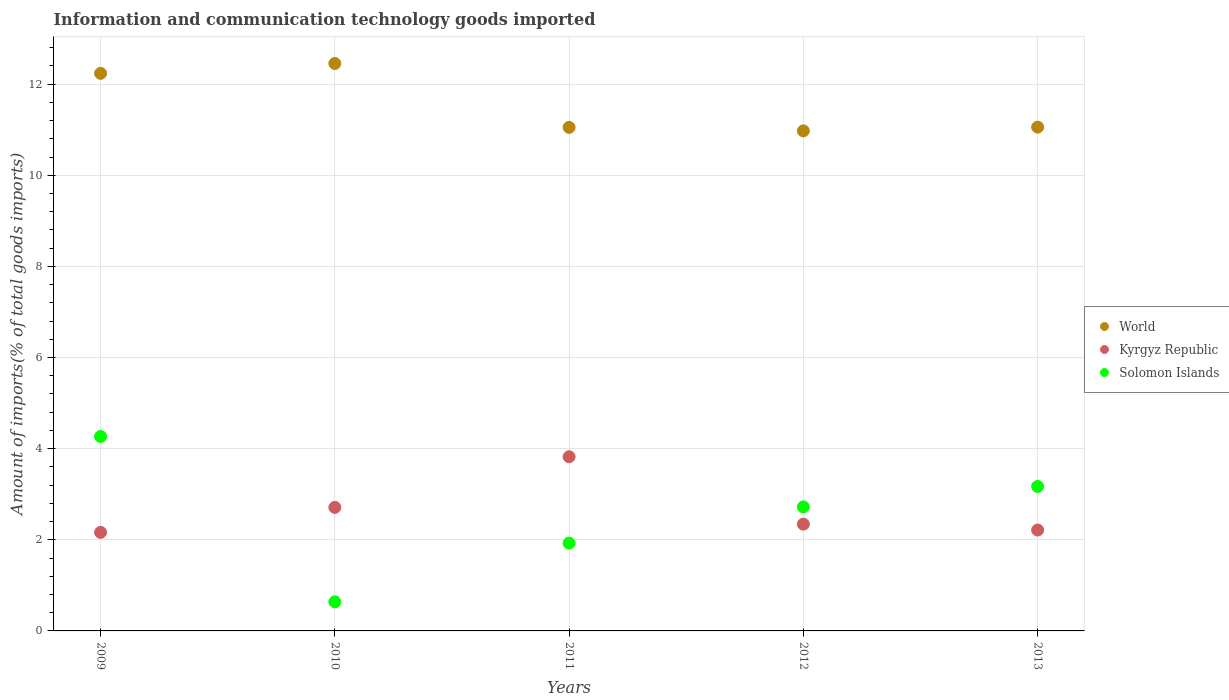How many different coloured dotlines are there?
Give a very brief answer. 3. What is the amount of goods imported in World in 2009?
Provide a succinct answer. 12.24. Across all years, what is the maximum amount of goods imported in Kyrgyz Republic?
Make the answer very short. 3.82. Across all years, what is the minimum amount of goods imported in World?
Keep it short and to the point. 10.97. What is the total amount of goods imported in Solomon Islands in the graph?
Give a very brief answer. 12.73. What is the difference between the amount of goods imported in World in 2009 and that in 2013?
Keep it short and to the point. 1.18. What is the difference between the amount of goods imported in World in 2011 and the amount of goods imported in Solomon Islands in 2010?
Make the answer very short. 10.41. What is the average amount of goods imported in Solomon Islands per year?
Provide a succinct answer. 2.55. In the year 2013, what is the difference between the amount of goods imported in World and amount of goods imported in Solomon Islands?
Offer a terse response. 7.89. In how many years, is the amount of goods imported in Kyrgyz Republic greater than 11.6 %?
Ensure brevity in your answer.  0. What is the ratio of the amount of goods imported in World in 2010 to that in 2013?
Offer a terse response. 1.13. Is the amount of goods imported in World in 2010 less than that in 2012?
Keep it short and to the point. No. Is the difference between the amount of goods imported in World in 2009 and 2013 greater than the difference between the amount of goods imported in Solomon Islands in 2009 and 2013?
Your answer should be compact. Yes. What is the difference between the highest and the second highest amount of goods imported in Solomon Islands?
Your answer should be very brief. 1.1. What is the difference between the highest and the lowest amount of goods imported in Solomon Islands?
Ensure brevity in your answer.  3.63. Does the amount of goods imported in Solomon Islands monotonically increase over the years?
Ensure brevity in your answer.  No. Is the amount of goods imported in Solomon Islands strictly less than the amount of goods imported in Kyrgyz Republic over the years?
Give a very brief answer. No. What is the difference between two consecutive major ticks on the Y-axis?
Keep it short and to the point. 2. How are the legend labels stacked?
Your answer should be very brief. Vertical. What is the title of the graph?
Make the answer very short. Information and communication technology goods imported. Does "Gambia, The" appear as one of the legend labels in the graph?
Your answer should be very brief. No. What is the label or title of the Y-axis?
Make the answer very short. Amount of imports(% of total goods imports). What is the Amount of imports(% of total goods imports) in World in 2009?
Offer a terse response. 12.24. What is the Amount of imports(% of total goods imports) of Kyrgyz Republic in 2009?
Make the answer very short. 2.16. What is the Amount of imports(% of total goods imports) of Solomon Islands in 2009?
Ensure brevity in your answer.  4.27. What is the Amount of imports(% of total goods imports) of World in 2010?
Provide a short and direct response. 12.45. What is the Amount of imports(% of total goods imports) in Kyrgyz Republic in 2010?
Provide a succinct answer. 2.71. What is the Amount of imports(% of total goods imports) in Solomon Islands in 2010?
Make the answer very short. 0.64. What is the Amount of imports(% of total goods imports) in World in 2011?
Keep it short and to the point. 11.05. What is the Amount of imports(% of total goods imports) in Kyrgyz Republic in 2011?
Offer a very short reply. 3.82. What is the Amount of imports(% of total goods imports) in Solomon Islands in 2011?
Your answer should be very brief. 1.93. What is the Amount of imports(% of total goods imports) of World in 2012?
Give a very brief answer. 10.97. What is the Amount of imports(% of total goods imports) of Kyrgyz Republic in 2012?
Give a very brief answer. 2.34. What is the Amount of imports(% of total goods imports) of Solomon Islands in 2012?
Ensure brevity in your answer.  2.72. What is the Amount of imports(% of total goods imports) of World in 2013?
Ensure brevity in your answer.  11.06. What is the Amount of imports(% of total goods imports) in Kyrgyz Republic in 2013?
Make the answer very short. 2.21. What is the Amount of imports(% of total goods imports) of Solomon Islands in 2013?
Ensure brevity in your answer.  3.17. Across all years, what is the maximum Amount of imports(% of total goods imports) in World?
Ensure brevity in your answer.  12.45. Across all years, what is the maximum Amount of imports(% of total goods imports) in Kyrgyz Republic?
Ensure brevity in your answer.  3.82. Across all years, what is the maximum Amount of imports(% of total goods imports) in Solomon Islands?
Ensure brevity in your answer.  4.27. Across all years, what is the minimum Amount of imports(% of total goods imports) in World?
Your answer should be compact. 10.97. Across all years, what is the minimum Amount of imports(% of total goods imports) of Kyrgyz Republic?
Make the answer very short. 2.16. Across all years, what is the minimum Amount of imports(% of total goods imports) of Solomon Islands?
Provide a succinct answer. 0.64. What is the total Amount of imports(% of total goods imports) of World in the graph?
Your answer should be compact. 57.77. What is the total Amount of imports(% of total goods imports) in Kyrgyz Republic in the graph?
Ensure brevity in your answer.  13.25. What is the total Amount of imports(% of total goods imports) of Solomon Islands in the graph?
Offer a very short reply. 12.73. What is the difference between the Amount of imports(% of total goods imports) in World in 2009 and that in 2010?
Keep it short and to the point. -0.22. What is the difference between the Amount of imports(% of total goods imports) in Kyrgyz Republic in 2009 and that in 2010?
Make the answer very short. -0.55. What is the difference between the Amount of imports(% of total goods imports) of Solomon Islands in 2009 and that in 2010?
Provide a succinct answer. 3.63. What is the difference between the Amount of imports(% of total goods imports) in World in 2009 and that in 2011?
Your answer should be compact. 1.19. What is the difference between the Amount of imports(% of total goods imports) in Kyrgyz Republic in 2009 and that in 2011?
Your answer should be very brief. -1.66. What is the difference between the Amount of imports(% of total goods imports) of Solomon Islands in 2009 and that in 2011?
Your response must be concise. 2.34. What is the difference between the Amount of imports(% of total goods imports) in World in 2009 and that in 2012?
Keep it short and to the point. 1.26. What is the difference between the Amount of imports(% of total goods imports) in Kyrgyz Republic in 2009 and that in 2012?
Provide a succinct answer. -0.18. What is the difference between the Amount of imports(% of total goods imports) in Solomon Islands in 2009 and that in 2012?
Offer a very short reply. 1.55. What is the difference between the Amount of imports(% of total goods imports) of World in 2009 and that in 2013?
Your answer should be compact. 1.18. What is the difference between the Amount of imports(% of total goods imports) of Kyrgyz Republic in 2009 and that in 2013?
Your answer should be very brief. -0.05. What is the difference between the Amount of imports(% of total goods imports) in Solomon Islands in 2009 and that in 2013?
Give a very brief answer. 1.1. What is the difference between the Amount of imports(% of total goods imports) of World in 2010 and that in 2011?
Offer a terse response. 1.4. What is the difference between the Amount of imports(% of total goods imports) in Kyrgyz Republic in 2010 and that in 2011?
Keep it short and to the point. -1.11. What is the difference between the Amount of imports(% of total goods imports) of Solomon Islands in 2010 and that in 2011?
Provide a succinct answer. -1.29. What is the difference between the Amount of imports(% of total goods imports) of World in 2010 and that in 2012?
Provide a short and direct response. 1.48. What is the difference between the Amount of imports(% of total goods imports) in Kyrgyz Republic in 2010 and that in 2012?
Your answer should be compact. 0.37. What is the difference between the Amount of imports(% of total goods imports) in Solomon Islands in 2010 and that in 2012?
Keep it short and to the point. -2.08. What is the difference between the Amount of imports(% of total goods imports) in World in 2010 and that in 2013?
Provide a short and direct response. 1.4. What is the difference between the Amount of imports(% of total goods imports) in Kyrgyz Republic in 2010 and that in 2013?
Offer a terse response. 0.5. What is the difference between the Amount of imports(% of total goods imports) in Solomon Islands in 2010 and that in 2013?
Ensure brevity in your answer.  -2.53. What is the difference between the Amount of imports(% of total goods imports) of World in 2011 and that in 2012?
Provide a succinct answer. 0.08. What is the difference between the Amount of imports(% of total goods imports) in Kyrgyz Republic in 2011 and that in 2012?
Provide a short and direct response. 1.48. What is the difference between the Amount of imports(% of total goods imports) of Solomon Islands in 2011 and that in 2012?
Keep it short and to the point. -0.8. What is the difference between the Amount of imports(% of total goods imports) of World in 2011 and that in 2013?
Keep it short and to the point. -0.01. What is the difference between the Amount of imports(% of total goods imports) of Kyrgyz Republic in 2011 and that in 2013?
Provide a short and direct response. 1.61. What is the difference between the Amount of imports(% of total goods imports) of Solomon Islands in 2011 and that in 2013?
Offer a very short reply. -1.24. What is the difference between the Amount of imports(% of total goods imports) of World in 2012 and that in 2013?
Your answer should be compact. -0.08. What is the difference between the Amount of imports(% of total goods imports) in Kyrgyz Republic in 2012 and that in 2013?
Keep it short and to the point. 0.13. What is the difference between the Amount of imports(% of total goods imports) in Solomon Islands in 2012 and that in 2013?
Give a very brief answer. -0.45. What is the difference between the Amount of imports(% of total goods imports) of World in 2009 and the Amount of imports(% of total goods imports) of Kyrgyz Republic in 2010?
Offer a very short reply. 9.53. What is the difference between the Amount of imports(% of total goods imports) of World in 2009 and the Amount of imports(% of total goods imports) of Solomon Islands in 2010?
Your response must be concise. 11.6. What is the difference between the Amount of imports(% of total goods imports) in Kyrgyz Republic in 2009 and the Amount of imports(% of total goods imports) in Solomon Islands in 2010?
Give a very brief answer. 1.52. What is the difference between the Amount of imports(% of total goods imports) of World in 2009 and the Amount of imports(% of total goods imports) of Kyrgyz Republic in 2011?
Provide a short and direct response. 8.41. What is the difference between the Amount of imports(% of total goods imports) of World in 2009 and the Amount of imports(% of total goods imports) of Solomon Islands in 2011?
Provide a succinct answer. 10.31. What is the difference between the Amount of imports(% of total goods imports) of Kyrgyz Republic in 2009 and the Amount of imports(% of total goods imports) of Solomon Islands in 2011?
Give a very brief answer. 0.24. What is the difference between the Amount of imports(% of total goods imports) of World in 2009 and the Amount of imports(% of total goods imports) of Kyrgyz Republic in 2012?
Your answer should be compact. 9.89. What is the difference between the Amount of imports(% of total goods imports) in World in 2009 and the Amount of imports(% of total goods imports) in Solomon Islands in 2012?
Your answer should be compact. 9.51. What is the difference between the Amount of imports(% of total goods imports) in Kyrgyz Republic in 2009 and the Amount of imports(% of total goods imports) in Solomon Islands in 2012?
Your response must be concise. -0.56. What is the difference between the Amount of imports(% of total goods imports) in World in 2009 and the Amount of imports(% of total goods imports) in Kyrgyz Republic in 2013?
Provide a succinct answer. 10.02. What is the difference between the Amount of imports(% of total goods imports) of World in 2009 and the Amount of imports(% of total goods imports) of Solomon Islands in 2013?
Keep it short and to the point. 9.07. What is the difference between the Amount of imports(% of total goods imports) in Kyrgyz Republic in 2009 and the Amount of imports(% of total goods imports) in Solomon Islands in 2013?
Provide a succinct answer. -1.01. What is the difference between the Amount of imports(% of total goods imports) of World in 2010 and the Amount of imports(% of total goods imports) of Kyrgyz Republic in 2011?
Provide a succinct answer. 8.63. What is the difference between the Amount of imports(% of total goods imports) of World in 2010 and the Amount of imports(% of total goods imports) of Solomon Islands in 2011?
Provide a succinct answer. 10.53. What is the difference between the Amount of imports(% of total goods imports) in Kyrgyz Republic in 2010 and the Amount of imports(% of total goods imports) in Solomon Islands in 2011?
Give a very brief answer. 0.78. What is the difference between the Amount of imports(% of total goods imports) in World in 2010 and the Amount of imports(% of total goods imports) in Kyrgyz Republic in 2012?
Make the answer very short. 10.11. What is the difference between the Amount of imports(% of total goods imports) in World in 2010 and the Amount of imports(% of total goods imports) in Solomon Islands in 2012?
Provide a short and direct response. 9.73. What is the difference between the Amount of imports(% of total goods imports) in Kyrgyz Republic in 2010 and the Amount of imports(% of total goods imports) in Solomon Islands in 2012?
Make the answer very short. -0.01. What is the difference between the Amount of imports(% of total goods imports) in World in 2010 and the Amount of imports(% of total goods imports) in Kyrgyz Republic in 2013?
Give a very brief answer. 10.24. What is the difference between the Amount of imports(% of total goods imports) of World in 2010 and the Amount of imports(% of total goods imports) of Solomon Islands in 2013?
Offer a terse response. 9.28. What is the difference between the Amount of imports(% of total goods imports) in Kyrgyz Republic in 2010 and the Amount of imports(% of total goods imports) in Solomon Islands in 2013?
Make the answer very short. -0.46. What is the difference between the Amount of imports(% of total goods imports) of World in 2011 and the Amount of imports(% of total goods imports) of Kyrgyz Republic in 2012?
Your response must be concise. 8.71. What is the difference between the Amount of imports(% of total goods imports) in World in 2011 and the Amount of imports(% of total goods imports) in Solomon Islands in 2012?
Give a very brief answer. 8.33. What is the difference between the Amount of imports(% of total goods imports) in Kyrgyz Republic in 2011 and the Amount of imports(% of total goods imports) in Solomon Islands in 2012?
Make the answer very short. 1.1. What is the difference between the Amount of imports(% of total goods imports) in World in 2011 and the Amount of imports(% of total goods imports) in Kyrgyz Republic in 2013?
Your response must be concise. 8.84. What is the difference between the Amount of imports(% of total goods imports) of World in 2011 and the Amount of imports(% of total goods imports) of Solomon Islands in 2013?
Make the answer very short. 7.88. What is the difference between the Amount of imports(% of total goods imports) of Kyrgyz Republic in 2011 and the Amount of imports(% of total goods imports) of Solomon Islands in 2013?
Make the answer very short. 0.65. What is the difference between the Amount of imports(% of total goods imports) of World in 2012 and the Amount of imports(% of total goods imports) of Kyrgyz Republic in 2013?
Your answer should be compact. 8.76. What is the difference between the Amount of imports(% of total goods imports) of World in 2012 and the Amount of imports(% of total goods imports) of Solomon Islands in 2013?
Offer a very short reply. 7.8. What is the difference between the Amount of imports(% of total goods imports) of Kyrgyz Republic in 2012 and the Amount of imports(% of total goods imports) of Solomon Islands in 2013?
Your answer should be compact. -0.83. What is the average Amount of imports(% of total goods imports) of World per year?
Give a very brief answer. 11.55. What is the average Amount of imports(% of total goods imports) in Kyrgyz Republic per year?
Your answer should be very brief. 2.65. What is the average Amount of imports(% of total goods imports) in Solomon Islands per year?
Your answer should be very brief. 2.55. In the year 2009, what is the difference between the Amount of imports(% of total goods imports) in World and Amount of imports(% of total goods imports) in Kyrgyz Republic?
Provide a short and direct response. 10.07. In the year 2009, what is the difference between the Amount of imports(% of total goods imports) of World and Amount of imports(% of total goods imports) of Solomon Islands?
Offer a very short reply. 7.97. In the year 2009, what is the difference between the Amount of imports(% of total goods imports) of Kyrgyz Republic and Amount of imports(% of total goods imports) of Solomon Islands?
Make the answer very short. -2.1. In the year 2010, what is the difference between the Amount of imports(% of total goods imports) in World and Amount of imports(% of total goods imports) in Kyrgyz Republic?
Give a very brief answer. 9.74. In the year 2010, what is the difference between the Amount of imports(% of total goods imports) of World and Amount of imports(% of total goods imports) of Solomon Islands?
Offer a terse response. 11.81. In the year 2010, what is the difference between the Amount of imports(% of total goods imports) of Kyrgyz Republic and Amount of imports(% of total goods imports) of Solomon Islands?
Your answer should be very brief. 2.07. In the year 2011, what is the difference between the Amount of imports(% of total goods imports) of World and Amount of imports(% of total goods imports) of Kyrgyz Republic?
Your answer should be very brief. 7.23. In the year 2011, what is the difference between the Amount of imports(% of total goods imports) of World and Amount of imports(% of total goods imports) of Solomon Islands?
Make the answer very short. 9.12. In the year 2011, what is the difference between the Amount of imports(% of total goods imports) of Kyrgyz Republic and Amount of imports(% of total goods imports) of Solomon Islands?
Your response must be concise. 1.9. In the year 2012, what is the difference between the Amount of imports(% of total goods imports) of World and Amount of imports(% of total goods imports) of Kyrgyz Republic?
Offer a very short reply. 8.63. In the year 2012, what is the difference between the Amount of imports(% of total goods imports) in World and Amount of imports(% of total goods imports) in Solomon Islands?
Provide a succinct answer. 8.25. In the year 2012, what is the difference between the Amount of imports(% of total goods imports) in Kyrgyz Republic and Amount of imports(% of total goods imports) in Solomon Islands?
Offer a terse response. -0.38. In the year 2013, what is the difference between the Amount of imports(% of total goods imports) in World and Amount of imports(% of total goods imports) in Kyrgyz Republic?
Provide a short and direct response. 8.84. In the year 2013, what is the difference between the Amount of imports(% of total goods imports) in World and Amount of imports(% of total goods imports) in Solomon Islands?
Give a very brief answer. 7.89. In the year 2013, what is the difference between the Amount of imports(% of total goods imports) of Kyrgyz Republic and Amount of imports(% of total goods imports) of Solomon Islands?
Keep it short and to the point. -0.96. What is the ratio of the Amount of imports(% of total goods imports) in World in 2009 to that in 2010?
Your answer should be very brief. 0.98. What is the ratio of the Amount of imports(% of total goods imports) of Kyrgyz Republic in 2009 to that in 2010?
Offer a very short reply. 0.8. What is the ratio of the Amount of imports(% of total goods imports) in Solomon Islands in 2009 to that in 2010?
Ensure brevity in your answer.  6.68. What is the ratio of the Amount of imports(% of total goods imports) in World in 2009 to that in 2011?
Offer a very short reply. 1.11. What is the ratio of the Amount of imports(% of total goods imports) in Kyrgyz Republic in 2009 to that in 2011?
Keep it short and to the point. 0.57. What is the ratio of the Amount of imports(% of total goods imports) in Solomon Islands in 2009 to that in 2011?
Offer a very short reply. 2.22. What is the ratio of the Amount of imports(% of total goods imports) in World in 2009 to that in 2012?
Your answer should be very brief. 1.11. What is the ratio of the Amount of imports(% of total goods imports) of Kyrgyz Republic in 2009 to that in 2012?
Your response must be concise. 0.92. What is the ratio of the Amount of imports(% of total goods imports) of Solomon Islands in 2009 to that in 2012?
Your response must be concise. 1.57. What is the ratio of the Amount of imports(% of total goods imports) in World in 2009 to that in 2013?
Ensure brevity in your answer.  1.11. What is the ratio of the Amount of imports(% of total goods imports) of Kyrgyz Republic in 2009 to that in 2013?
Provide a succinct answer. 0.98. What is the ratio of the Amount of imports(% of total goods imports) of Solomon Islands in 2009 to that in 2013?
Offer a terse response. 1.35. What is the ratio of the Amount of imports(% of total goods imports) in World in 2010 to that in 2011?
Provide a short and direct response. 1.13. What is the ratio of the Amount of imports(% of total goods imports) of Kyrgyz Republic in 2010 to that in 2011?
Provide a short and direct response. 0.71. What is the ratio of the Amount of imports(% of total goods imports) of Solomon Islands in 2010 to that in 2011?
Offer a terse response. 0.33. What is the ratio of the Amount of imports(% of total goods imports) of World in 2010 to that in 2012?
Ensure brevity in your answer.  1.13. What is the ratio of the Amount of imports(% of total goods imports) in Kyrgyz Republic in 2010 to that in 2012?
Give a very brief answer. 1.16. What is the ratio of the Amount of imports(% of total goods imports) in Solomon Islands in 2010 to that in 2012?
Your answer should be very brief. 0.23. What is the ratio of the Amount of imports(% of total goods imports) of World in 2010 to that in 2013?
Your response must be concise. 1.13. What is the ratio of the Amount of imports(% of total goods imports) of Kyrgyz Republic in 2010 to that in 2013?
Make the answer very short. 1.22. What is the ratio of the Amount of imports(% of total goods imports) of Solomon Islands in 2010 to that in 2013?
Offer a terse response. 0.2. What is the ratio of the Amount of imports(% of total goods imports) in World in 2011 to that in 2012?
Make the answer very short. 1.01. What is the ratio of the Amount of imports(% of total goods imports) in Kyrgyz Republic in 2011 to that in 2012?
Give a very brief answer. 1.63. What is the ratio of the Amount of imports(% of total goods imports) in Solomon Islands in 2011 to that in 2012?
Your answer should be compact. 0.71. What is the ratio of the Amount of imports(% of total goods imports) in World in 2011 to that in 2013?
Your answer should be very brief. 1. What is the ratio of the Amount of imports(% of total goods imports) in Kyrgyz Republic in 2011 to that in 2013?
Offer a terse response. 1.73. What is the ratio of the Amount of imports(% of total goods imports) of Solomon Islands in 2011 to that in 2013?
Ensure brevity in your answer.  0.61. What is the ratio of the Amount of imports(% of total goods imports) of World in 2012 to that in 2013?
Provide a succinct answer. 0.99. What is the ratio of the Amount of imports(% of total goods imports) of Kyrgyz Republic in 2012 to that in 2013?
Ensure brevity in your answer.  1.06. What is the ratio of the Amount of imports(% of total goods imports) in Solomon Islands in 2012 to that in 2013?
Your answer should be very brief. 0.86. What is the difference between the highest and the second highest Amount of imports(% of total goods imports) of World?
Your answer should be compact. 0.22. What is the difference between the highest and the second highest Amount of imports(% of total goods imports) of Kyrgyz Republic?
Give a very brief answer. 1.11. What is the difference between the highest and the second highest Amount of imports(% of total goods imports) in Solomon Islands?
Ensure brevity in your answer.  1.1. What is the difference between the highest and the lowest Amount of imports(% of total goods imports) of World?
Your answer should be compact. 1.48. What is the difference between the highest and the lowest Amount of imports(% of total goods imports) in Kyrgyz Republic?
Your response must be concise. 1.66. What is the difference between the highest and the lowest Amount of imports(% of total goods imports) of Solomon Islands?
Offer a very short reply. 3.63. 